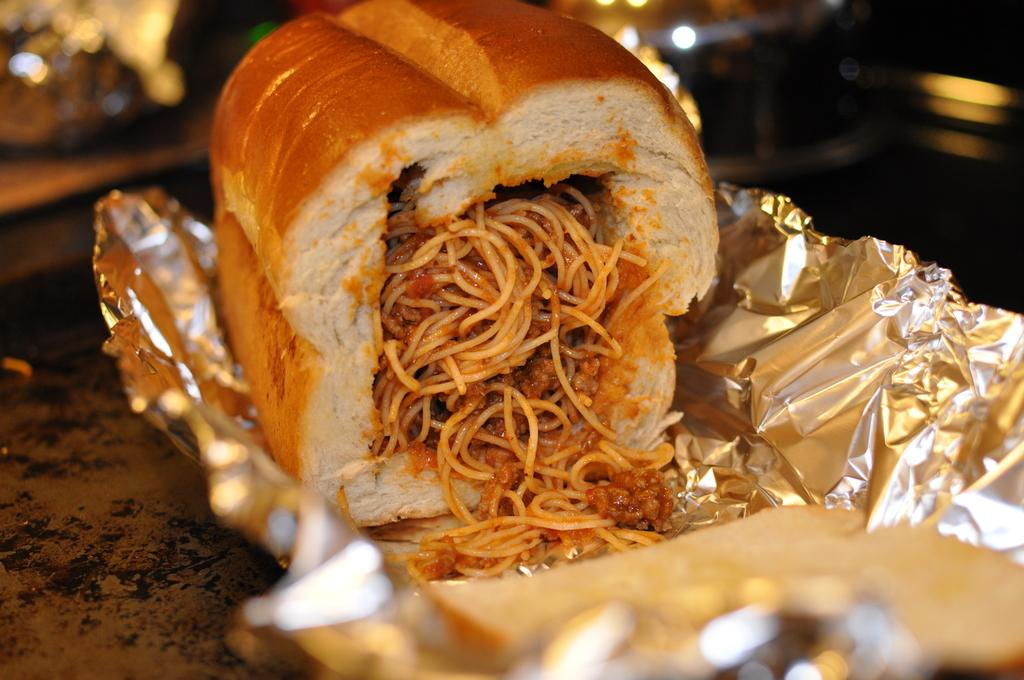What is the main subject of the image? The main subject of the image is food. How is the food packaged or presented? The food is on a silver wrapper. What can be inferred about the image's focus or clarity? The image is blurry at the back. What type of surface is the food placed on? There is a table in the image. Can you see a baby jumping on the table in the image? There is no baby or jumping activity present in the image. What type of pet is sitting on the table next to the food? There is no pet visible in the image. 